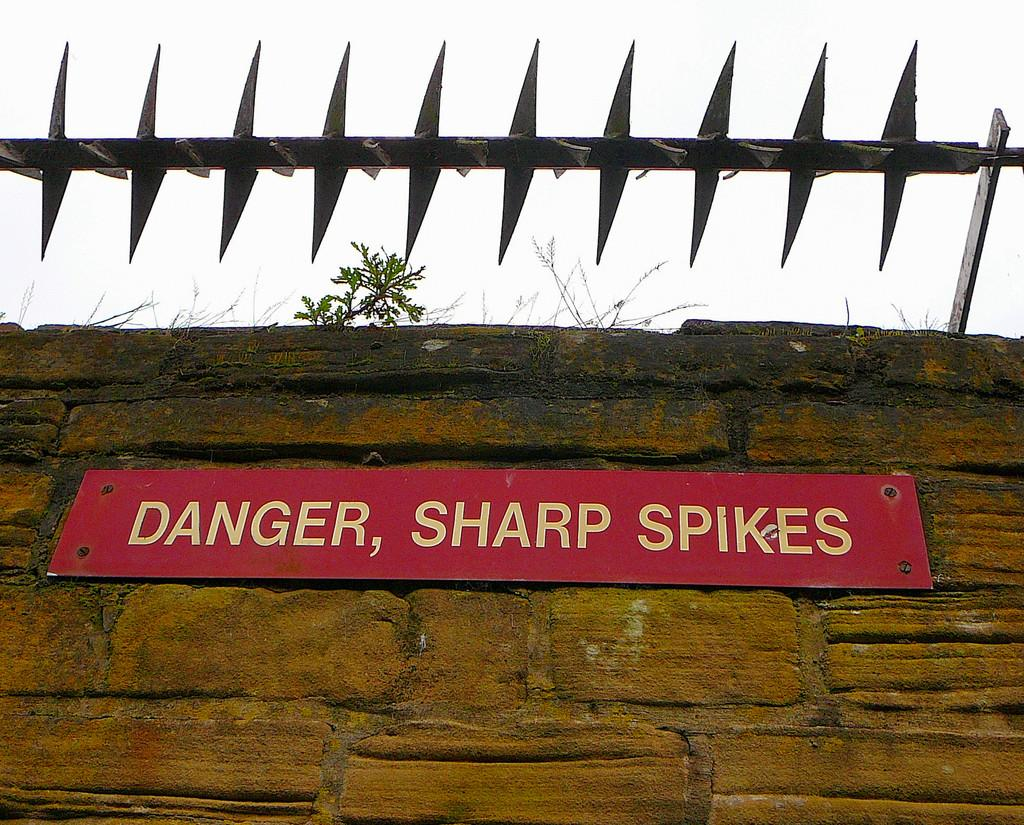What type of barrier can be seen in the image? There is a picket fence in the image. What other structure is present in the image? There is a stone wall in the image. What object has text on it in the image? There is a board in the image with text on it. What type of vegetation is in the image? There is a plant in the image. What is the color of the sky in the image? The sky is white in the image. How many flies are sitting on the plate in the image? There is no plate or flies present in the image. What type of request is being made on the board in the image? There is no request present on the board in the image; it only has text. 